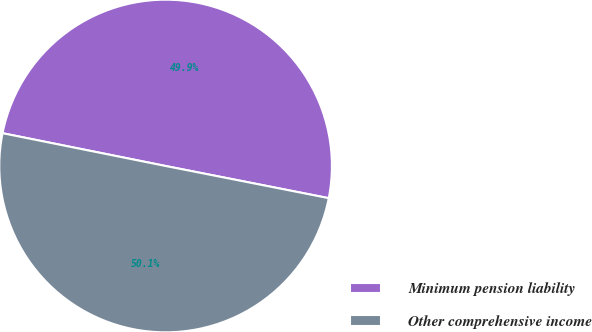Convert chart to OTSL. <chart><loc_0><loc_0><loc_500><loc_500><pie_chart><fcel>Minimum pension liability<fcel>Other comprehensive income<nl><fcel>49.94%<fcel>50.06%<nl></chart> 